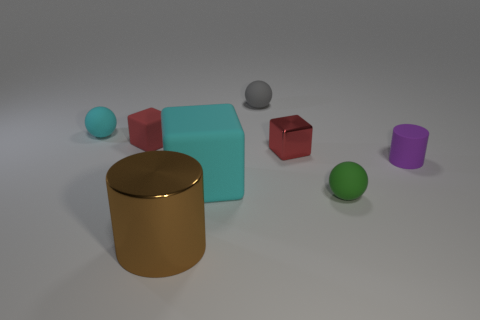Add 1 red cubes. How many objects exist? 9 Subtract all balls. How many objects are left? 5 Add 5 large cubes. How many large cubes are left? 6 Add 1 large red shiny blocks. How many large red shiny blocks exist? 1 Subtract 0 red balls. How many objects are left? 8 Subtract all small brown balls. Subtract all small purple things. How many objects are left? 7 